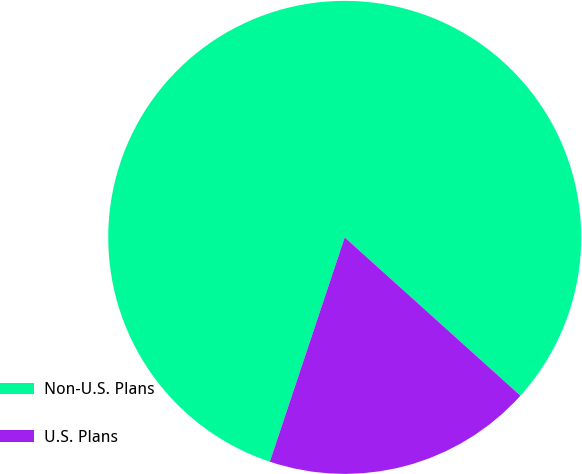<chart> <loc_0><loc_0><loc_500><loc_500><pie_chart><fcel>Non-U.S. Plans<fcel>U.S. Plans<nl><fcel>81.54%<fcel>18.46%<nl></chart> 